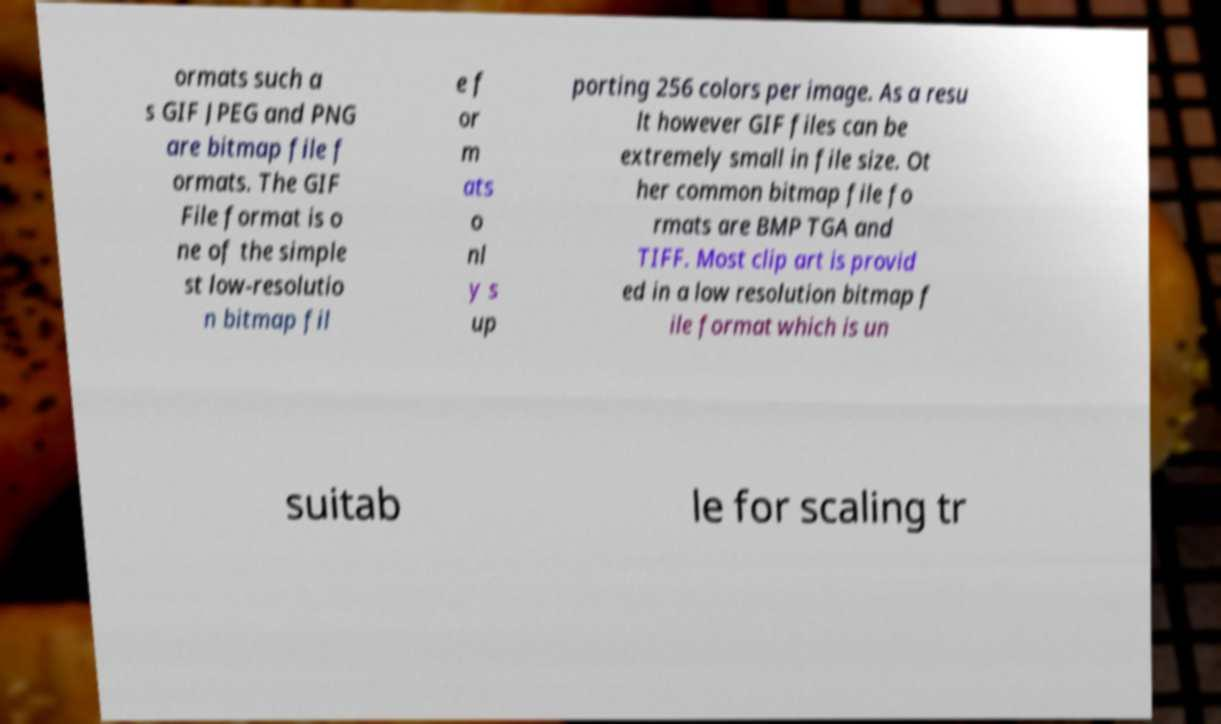Can you read and provide the text displayed in the image?This photo seems to have some interesting text. Can you extract and type it out for me? ormats such a s GIF JPEG and PNG are bitmap file f ormats. The GIF File format is o ne of the simple st low-resolutio n bitmap fil e f or m ats o nl y s up porting 256 colors per image. As a resu lt however GIF files can be extremely small in file size. Ot her common bitmap file fo rmats are BMP TGA and TIFF. Most clip art is provid ed in a low resolution bitmap f ile format which is un suitab le for scaling tr 